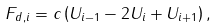Convert formula to latex. <formula><loc_0><loc_0><loc_500><loc_500>F _ { d , i } = c \left ( U _ { i - 1 } - 2 U _ { i } + U _ { i + 1 } \right ) ,</formula> 